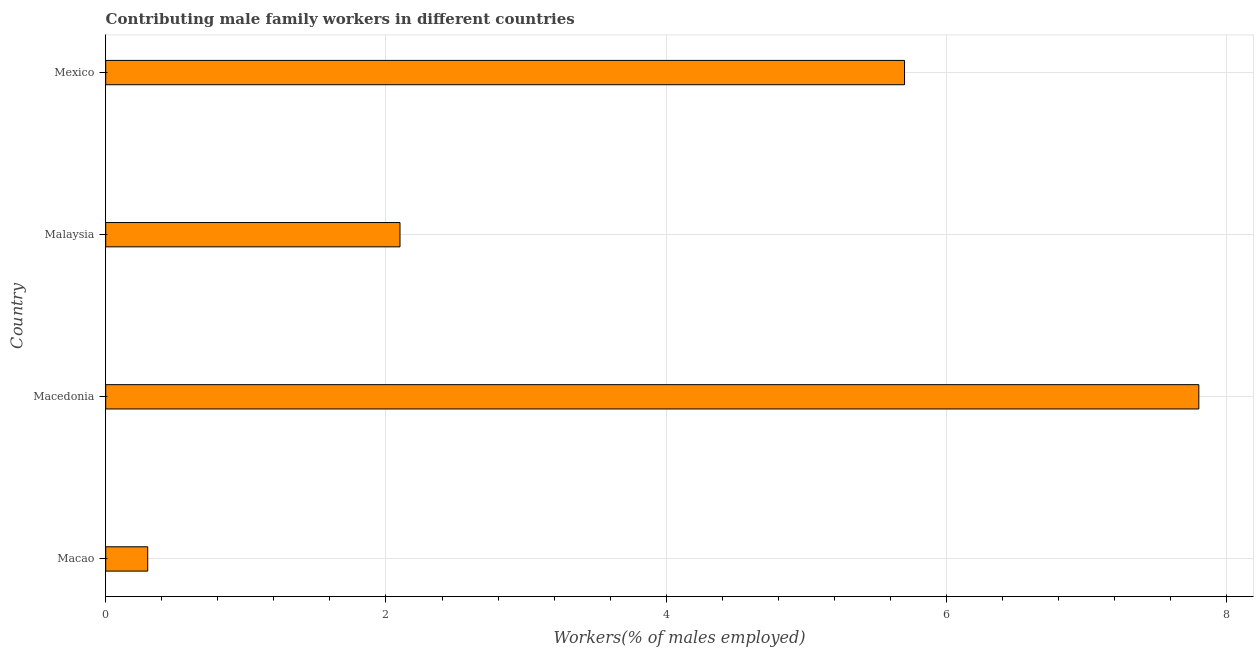What is the title of the graph?
Your response must be concise. Contributing male family workers in different countries. What is the label or title of the X-axis?
Keep it short and to the point. Workers(% of males employed). What is the label or title of the Y-axis?
Offer a very short reply. Country. What is the contributing male family workers in Mexico?
Provide a succinct answer. 5.7. Across all countries, what is the maximum contributing male family workers?
Your answer should be very brief. 7.8. Across all countries, what is the minimum contributing male family workers?
Your response must be concise. 0.3. In which country was the contributing male family workers maximum?
Offer a terse response. Macedonia. In which country was the contributing male family workers minimum?
Offer a terse response. Macao. What is the sum of the contributing male family workers?
Offer a terse response. 15.9. What is the average contributing male family workers per country?
Your answer should be very brief. 3.98. What is the median contributing male family workers?
Provide a short and direct response. 3.9. What is the ratio of the contributing male family workers in Macao to that in Mexico?
Your answer should be very brief. 0.05. Is the contributing male family workers in Macao less than that in Macedonia?
Provide a short and direct response. Yes. Is the difference between the contributing male family workers in Macao and Macedonia greater than the difference between any two countries?
Offer a very short reply. Yes. What is the difference between the highest and the lowest contributing male family workers?
Offer a very short reply. 7.5. How many bars are there?
Make the answer very short. 4. Are all the bars in the graph horizontal?
Your response must be concise. Yes. How many countries are there in the graph?
Provide a short and direct response. 4. Are the values on the major ticks of X-axis written in scientific E-notation?
Your response must be concise. No. What is the Workers(% of males employed) in Macao?
Keep it short and to the point. 0.3. What is the Workers(% of males employed) in Macedonia?
Keep it short and to the point. 7.8. What is the Workers(% of males employed) of Malaysia?
Provide a succinct answer. 2.1. What is the Workers(% of males employed) in Mexico?
Make the answer very short. 5.7. What is the difference between the Workers(% of males employed) in Macao and Macedonia?
Provide a short and direct response. -7.5. What is the difference between the Workers(% of males employed) in Macao and Mexico?
Provide a short and direct response. -5.4. What is the difference between the Workers(% of males employed) in Macedonia and Malaysia?
Your answer should be very brief. 5.7. What is the difference between the Workers(% of males employed) in Macedonia and Mexico?
Your answer should be compact. 2.1. What is the difference between the Workers(% of males employed) in Malaysia and Mexico?
Offer a terse response. -3.6. What is the ratio of the Workers(% of males employed) in Macao to that in Macedonia?
Make the answer very short. 0.04. What is the ratio of the Workers(% of males employed) in Macao to that in Malaysia?
Your response must be concise. 0.14. What is the ratio of the Workers(% of males employed) in Macao to that in Mexico?
Keep it short and to the point. 0.05. What is the ratio of the Workers(% of males employed) in Macedonia to that in Malaysia?
Keep it short and to the point. 3.71. What is the ratio of the Workers(% of males employed) in Macedonia to that in Mexico?
Give a very brief answer. 1.37. What is the ratio of the Workers(% of males employed) in Malaysia to that in Mexico?
Offer a very short reply. 0.37. 